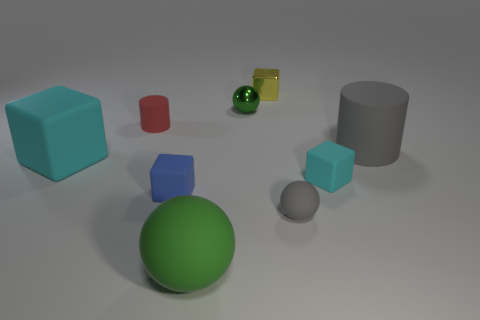Subtract all rubber blocks. How many blocks are left? 1 Subtract 1 spheres. How many spheres are left? 2 Subtract all green spheres. How many spheres are left? 1 Subtract all cylinders. How many objects are left? 7 Subtract all red cylinders. Subtract all yellow balls. How many cylinders are left? 1 Subtract all cyan blocks. How many green spheres are left? 2 Subtract all small blue matte cubes. Subtract all tiny yellow metal cubes. How many objects are left? 7 Add 2 metal things. How many metal things are left? 4 Add 1 cyan objects. How many cyan objects exist? 3 Add 1 large brown cubes. How many objects exist? 10 